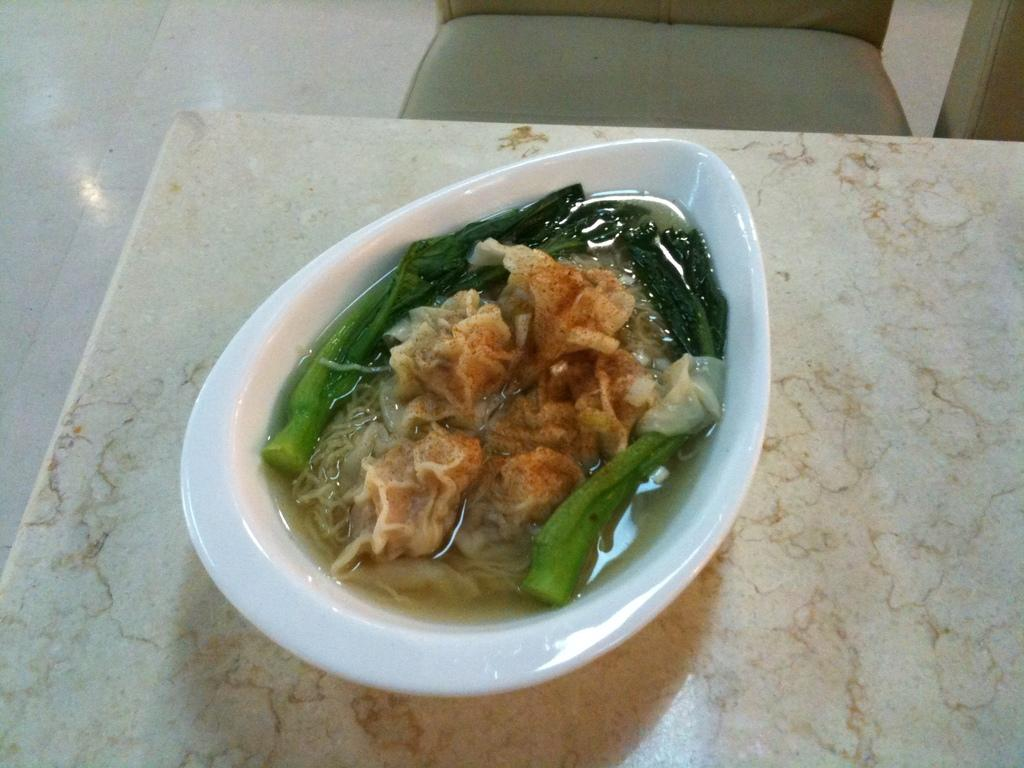What is the color of the bowl in the image? The bowl is white in color. What is inside the bowl? The bowl contains food items. Where is the bowl located in the image? The bowl is placed on a table. What type of throne is depicted in the image? There is no throne present in the image; it features a bowl on a table. How can one join the sun in the image? There is no sun present in the image, so it is not possible to join it. 